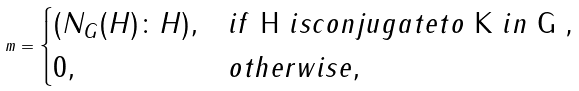<formula> <loc_0><loc_0><loc_500><loc_500>m = \begin{cases} ( N _ { G } ( H ) \colon H ) , & i f $ H $ i s c o n j u g a t e t o $ K $ i n $ G , $ \\ 0 , & o t h e r w i s e , \end{cases}</formula> 